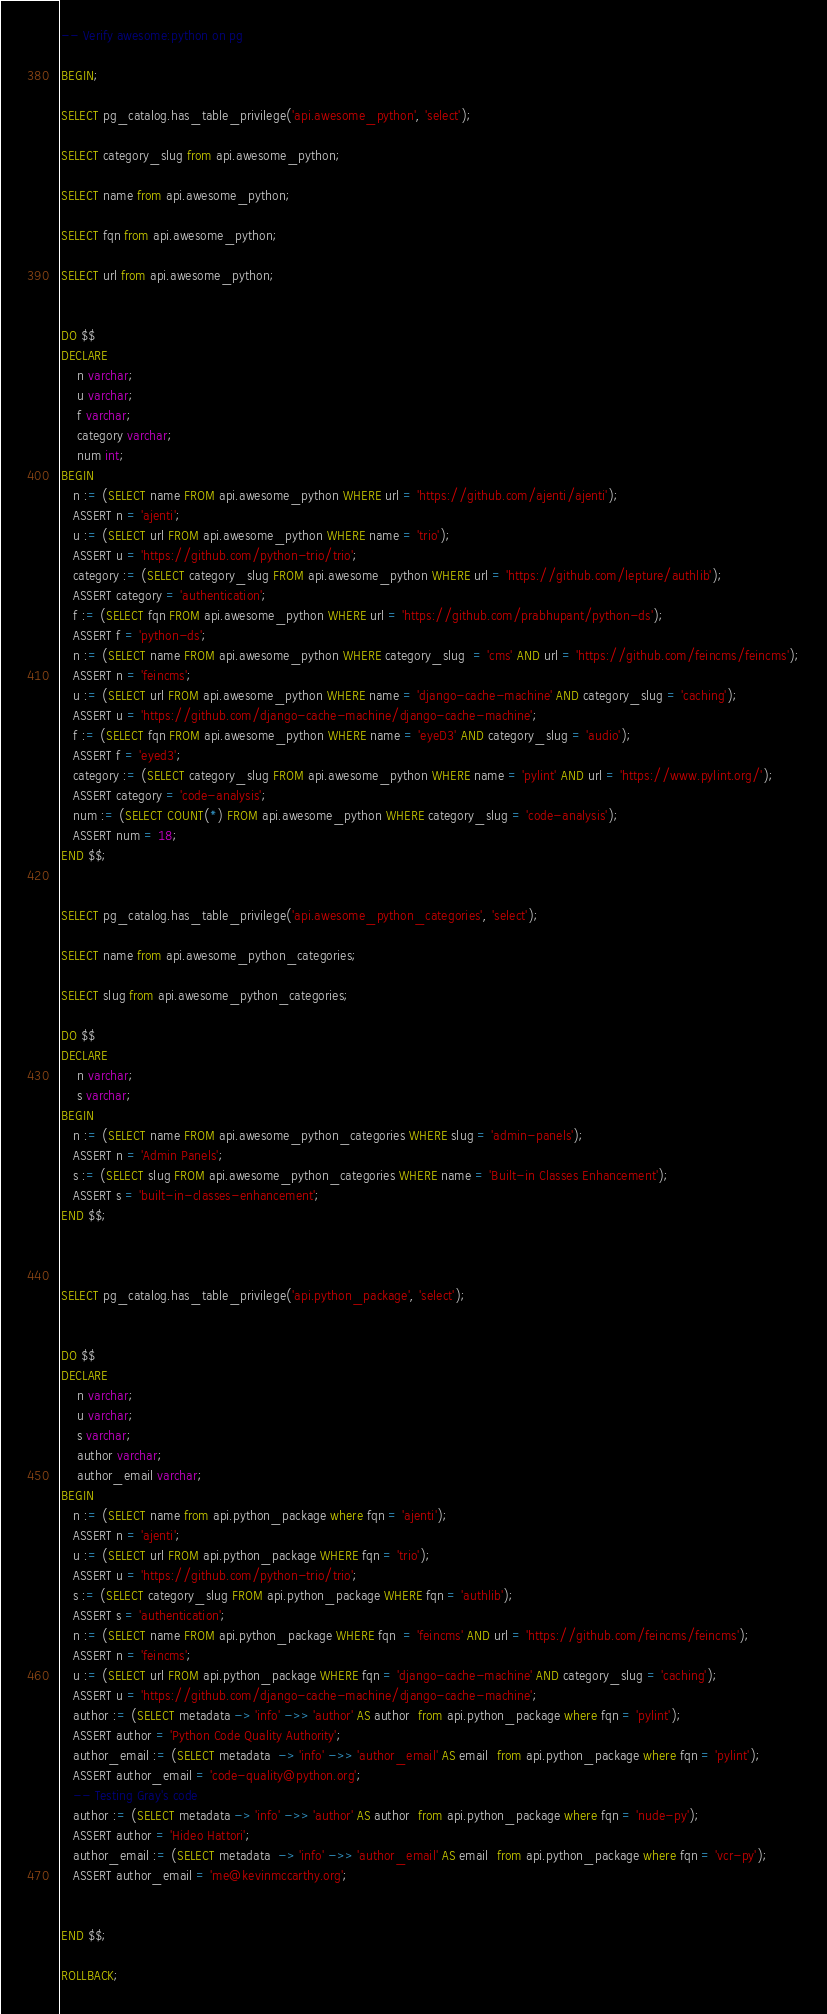Convert code to text. <code><loc_0><loc_0><loc_500><loc_500><_SQL_>-- Verify awesome:python on pg

BEGIN;

SELECT pg_catalog.has_table_privilege('api.awesome_python', 'select');

SELECT category_slug from api.awesome_python;

SELECT name from api.awesome_python;

SELECT fqn from api.awesome_python;

SELECT url from api.awesome_python;


DO $$
DECLARE
    n varchar;
    u varchar;
    f varchar;
    category varchar;
    num int;
BEGIN
   n := (SELECT name FROM api.awesome_python WHERE url = 'https://github.com/ajenti/ajenti');
   ASSERT n = 'ajenti';
   u := (SELECT url FROM api.awesome_python WHERE name = 'trio');
   ASSERT u = 'https://github.com/python-trio/trio';
   category := (SELECT category_slug FROM api.awesome_python WHERE url = 'https://github.com/lepture/authlib');
   ASSERT category = 'authentication';
   f := (SELECT fqn FROM api.awesome_python WHERE url = 'https://github.com/prabhupant/python-ds');
   ASSERT f = 'python-ds';
   n := (SELECT name FROM api.awesome_python WHERE category_slug  = 'cms' AND url = 'https://github.com/feincms/feincms');
   ASSERT n = 'feincms';
   u := (SELECT url FROM api.awesome_python WHERE name = 'django-cache-machine' AND category_slug = 'caching');
   ASSERT u = 'https://github.com/django-cache-machine/django-cache-machine';
   f := (SELECT fqn FROM api.awesome_python WHERE name = 'eyeD3' AND category_slug = 'audio');
   ASSERT f = 'eyed3';
   category := (SELECT category_slug FROM api.awesome_python WHERE name = 'pylint' AND url = 'https://www.pylint.org/');
   ASSERT category = 'code-analysis';
   num := (SELECT COUNT(*) FROM api.awesome_python WHERE category_slug = 'code-analysis');
   ASSERT num = 18;
END $$;


SELECT pg_catalog.has_table_privilege('api.awesome_python_categories', 'select');

SELECT name from api.awesome_python_categories;

SELECT slug from api.awesome_python_categories;

DO $$
DECLARE
    n varchar;
    s varchar;
BEGIN
   n := (SELECT name FROM api.awesome_python_categories WHERE slug = 'admin-panels');
   ASSERT n = 'Admin Panels';
   s := (SELECT slug FROM api.awesome_python_categories WHERE name = 'Built-in Classes Enhancement');
   ASSERT s = 'built-in-classes-enhancement';
END $$;



SELECT pg_catalog.has_table_privilege('api.python_package', 'select');


DO $$
DECLARE
    n varchar;
    u varchar;
    s varchar;
    author varchar;
    author_email varchar;
BEGIN
   n := (SELECT name from api.python_package where fqn = 'ajenti');
   ASSERT n = 'ajenti';
   u := (SELECT url FROM api.python_package WHERE fqn = 'trio');
   ASSERT u = 'https://github.com/python-trio/trio';
   s := (SELECT category_slug FROM api.python_package WHERE fqn = 'authlib');
   ASSERT s = 'authentication';
   n := (SELECT name FROM api.python_package WHERE fqn  = 'feincms' AND url = 'https://github.com/feincms/feincms');
   ASSERT n = 'feincms';
   u := (SELECT url FROM api.python_package WHERE fqn = 'django-cache-machine' AND category_slug = 'caching');
   ASSERT u = 'https://github.com/django-cache-machine/django-cache-machine';
   author := (SELECT metadata -> 'info' ->> 'author' AS author  from api.python_package where fqn = 'pylint');
   ASSERT author = 'Python Code Quality Authority';
   author_email := (SELECT metadata  -> 'info' ->> 'author_email' AS email  from api.python_package where fqn = 'pylint');
   ASSERT author_email = 'code-quality@python.org';
   -- Testing Gray's code
   author := (SELECT metadata -> 'info' ->> 'author' AS author  from api.python_package where fqn = 'nude-py');
   ASSERT author = 'Hideo Hattori';
   author_email := (SELECT metadata  -> 'info' ->> 'author_email' AS email  from api.python_package where fqn = 'vcr-py');
   ASSERT author_email = 'me@kevinmccarthy.org';


END $$;

ROLLBACK;
</code> 